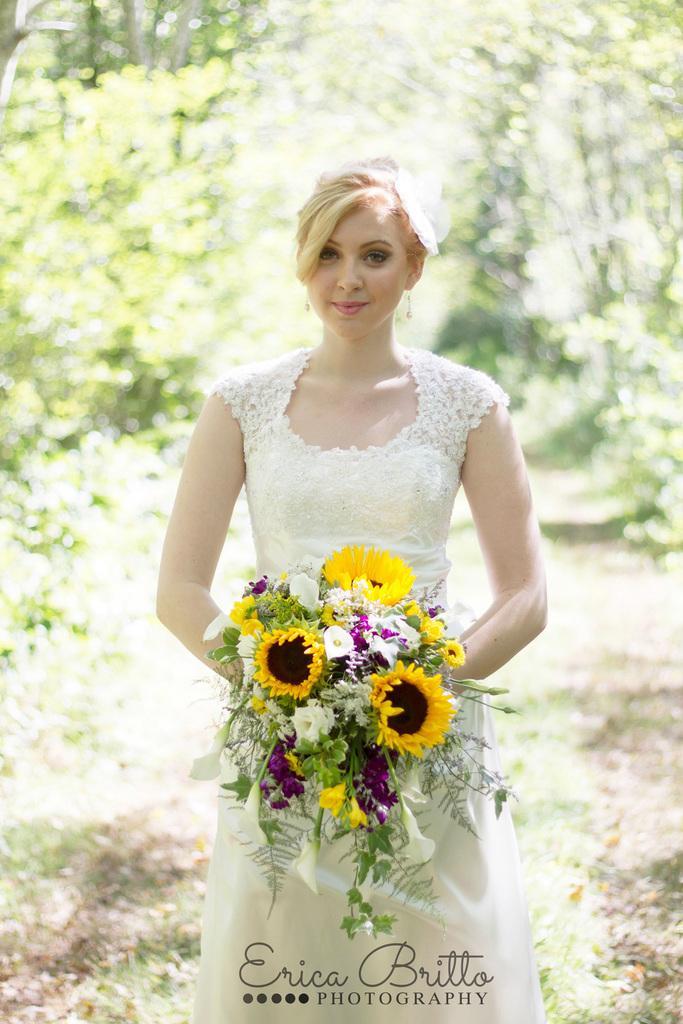How would you summarize this image in a sentence or two? In this image there is ground at the bottom. There is a person standing and holding an object in the foreground. There are trees in the background. 